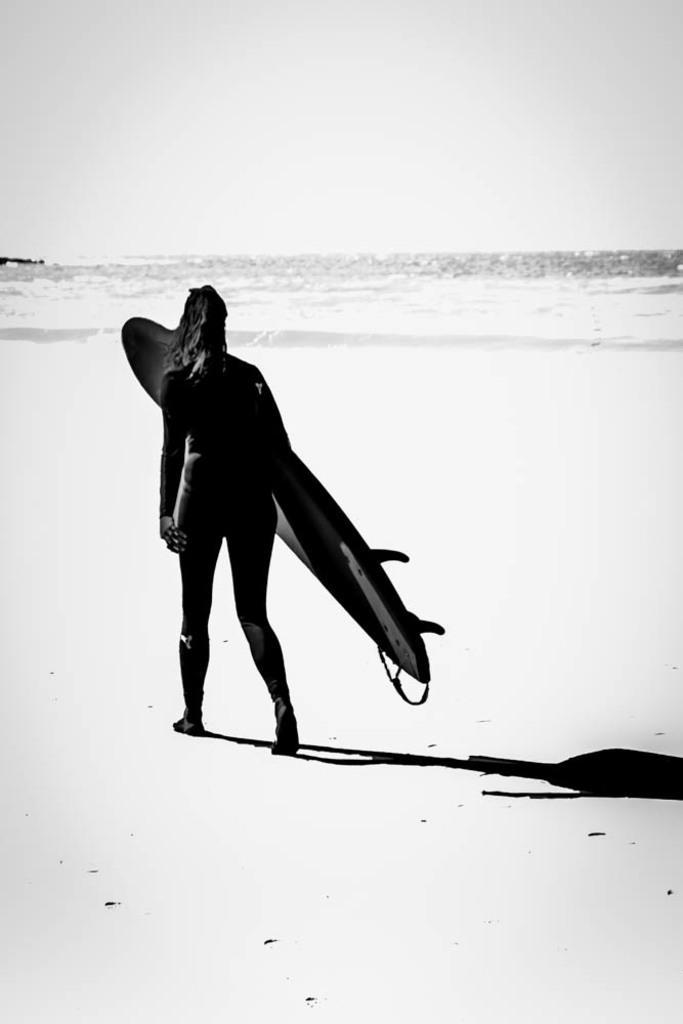Could you give a brief overview of what you see in this image? In this picture we can see woman carrying surfboard with her and walking and in background we can see water i think this is black and white picture. 